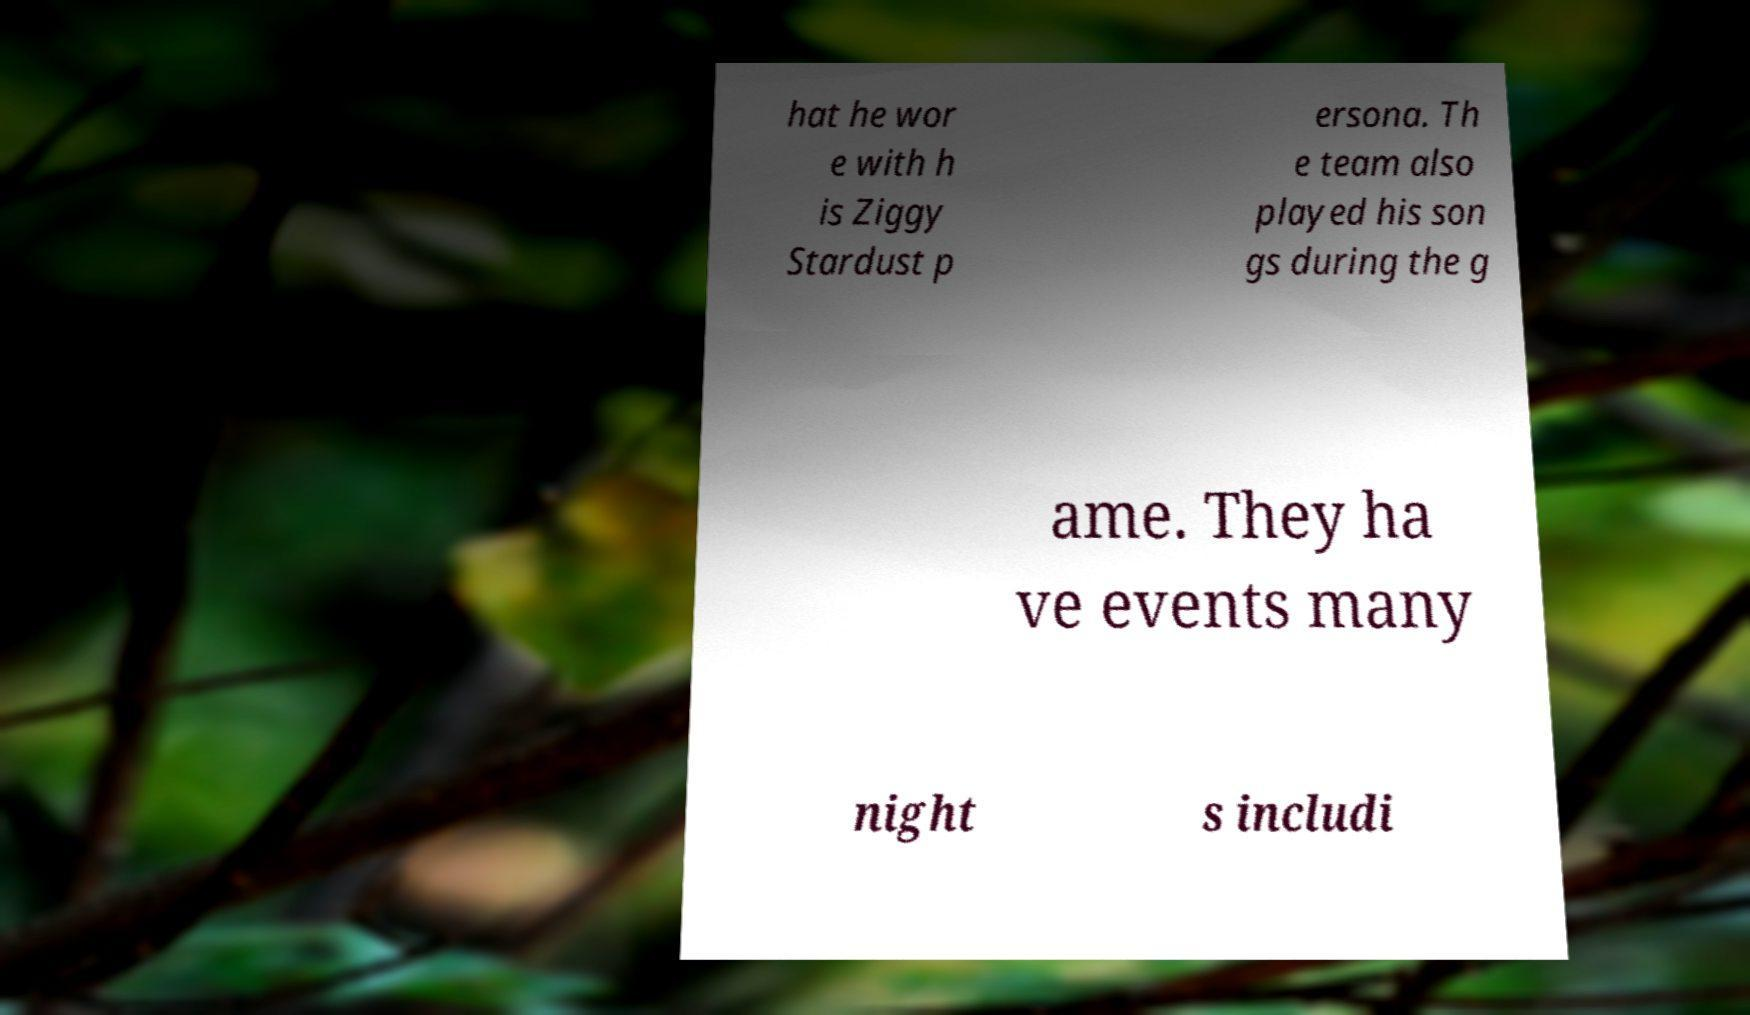Could you assist in decoding the text presented in this image and type it out clearly? hat he wor e with h is Ziggy Stardust p ersona. Th e team also played his son gs during the g ame. They ha ve events many night s includi 